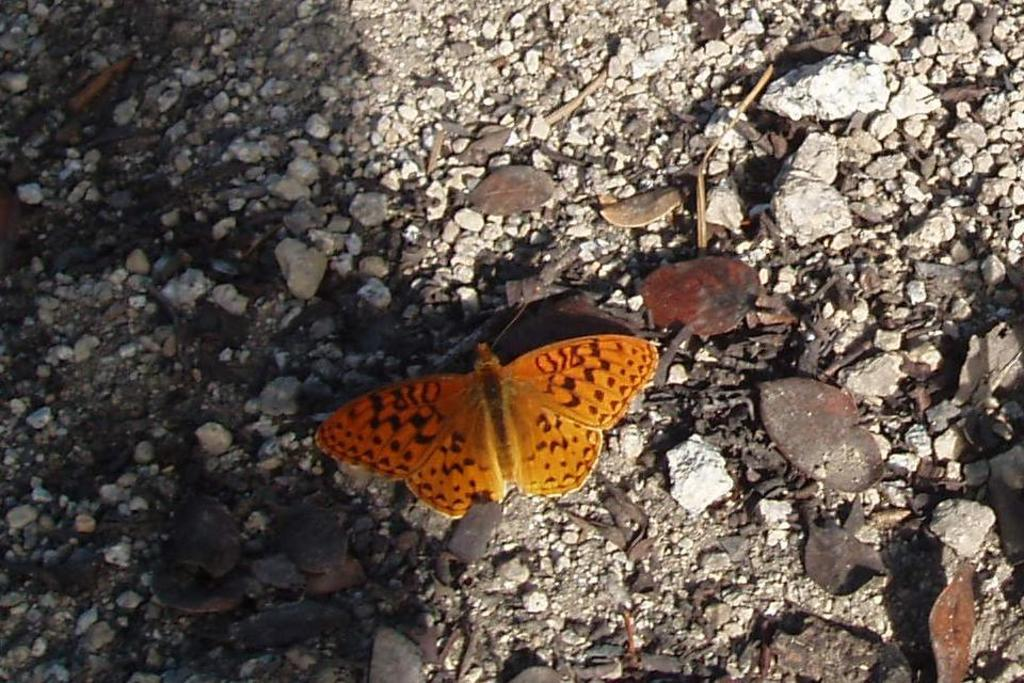What type of natural objects can be seen in the image? There are stones and dried leaves in the image. Are there any living creatures visible in the image? Yes, there is a butterfly in the image. What book is the butterfly reading in the image? There is no book or reading activity present in the image; the butterfly is simply flying among the stones and dried leaves. 